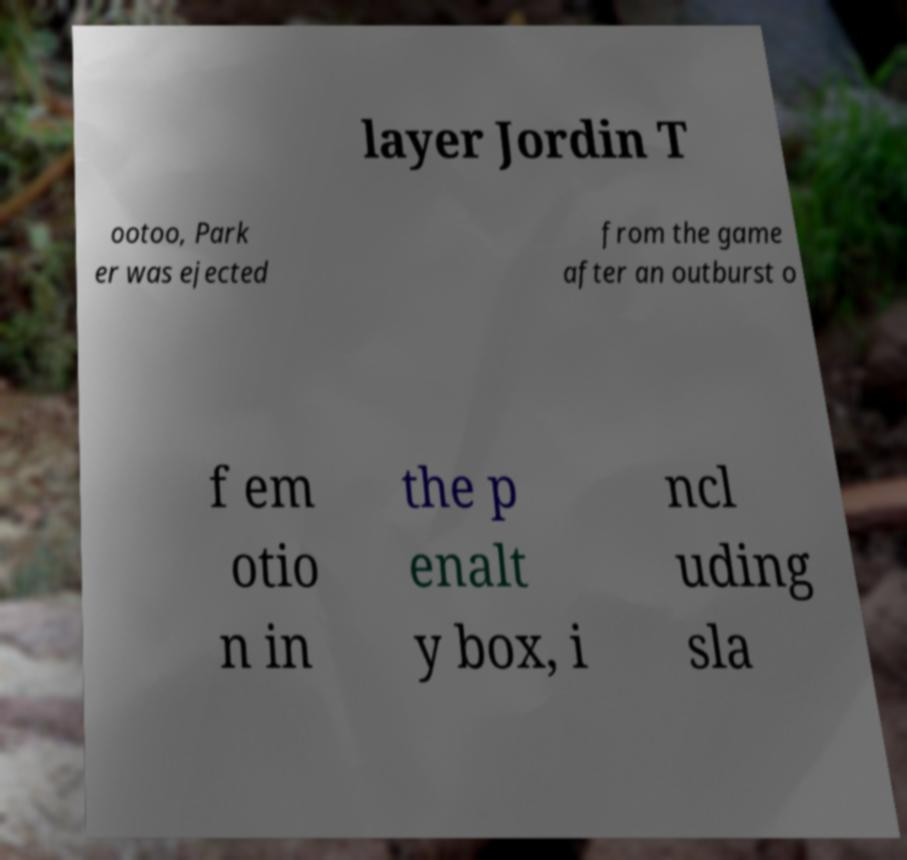There's text embedded in this image that I need extracted. Can you transcribe it verbatim? layer Jordin T ootoo, Park er was ejected from the game after an outburst o f em otio n in the p enalt y box, i ncl uding sla 